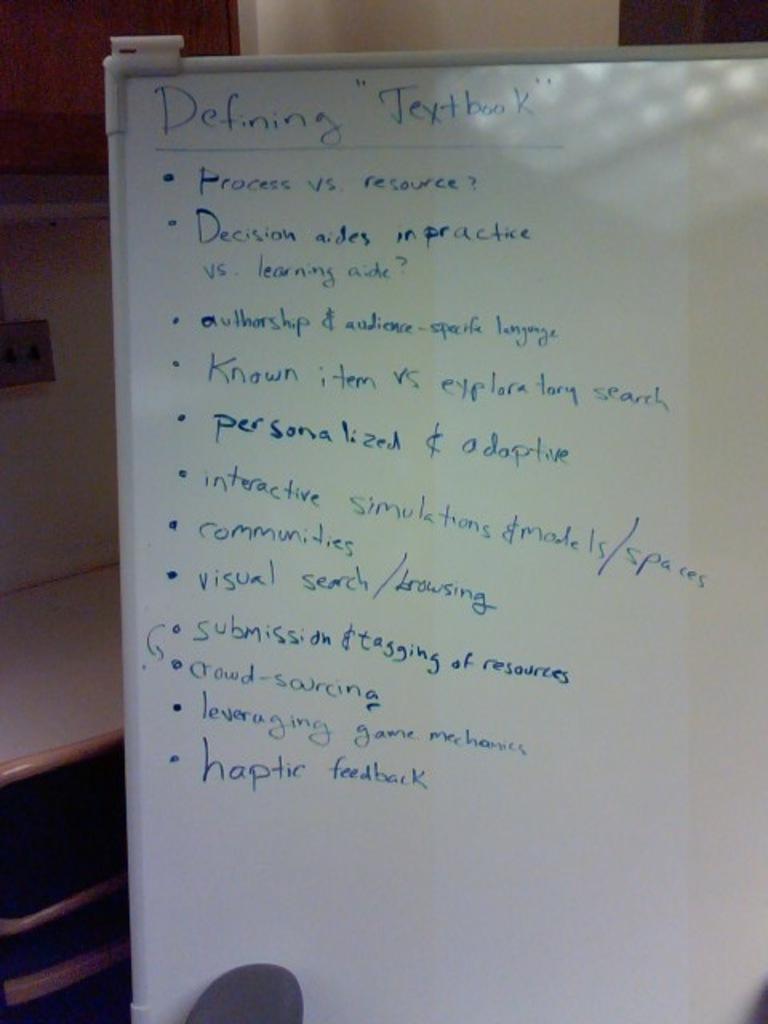What kind of feedback is the bottom entry seeking?
Provide a short and direct response. Haptic. 